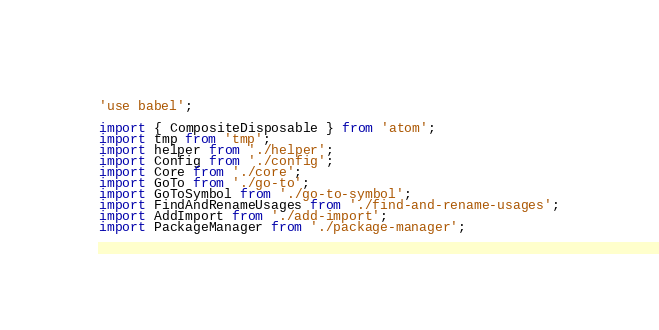Convert code to text. <code><loc_0><loc_0><loc_500><loc_500><_JavaScript_>'use babel';

import { CompositeDisposable } from 'atom';
import tmp from 'tmp';
import helper from './helper';
import Config from './config';
import Core from './core';
import GoTo from './go-to';
import GoToSymbol from './go-to-symbol';
import FindAndRenameUsages from './find-and-rename-usages';
import AddImport from './add-import';
import PackageManager from './package-manager';</code> 